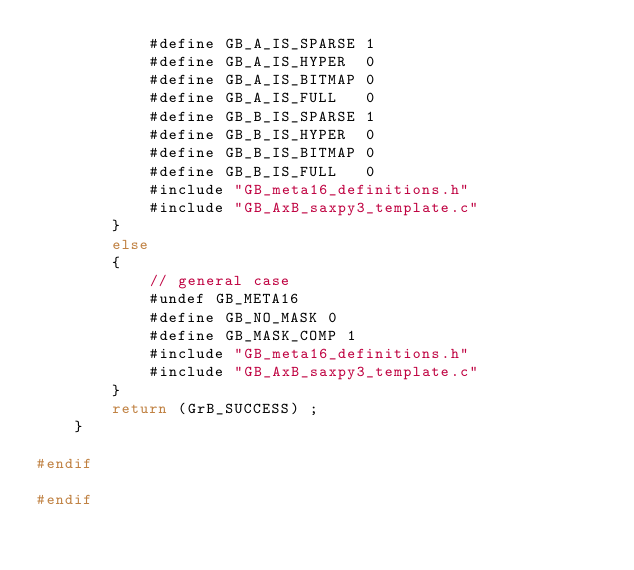Convert code to text. <code><loc_0><loc_0><loc_500><loc_500><_C_>            #define GB_A_IS_SPARSE 1
            #define GB_A_IS_HYPER  0
            #define GB_A_IS_BITMAP 0
            #define GB_A_IS_FULL   0
            #define GB_B_IS_SPARSE 1
            #define GB_B_IS_HYPER  0
            #define GB_B_IS_BITMAP 0
            #define GB_B_IS_FULL   0
            #include "GB_meta16_definitions.h"
            #include "GB_AxB_saxpy3_template.c"
        }
        else
        {
            // general case
            #undef GB_META16
            #define GB_NO_MASK 0
            #define GB_MASK_COMP 1
            #include "GB_meta16_definitions.h"
            #include "GB_AxB_saxpy3_template.c"
        }
        return (GrB_SUCCESS) ;
    }

#endif

#endif

</code> 